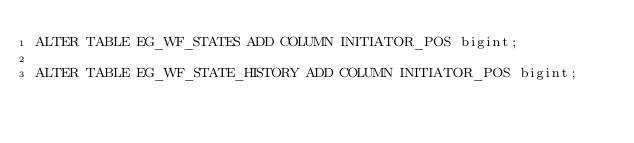<code> <loc_0><loc_0><loc_500><loc_500><_SQL_>ALTER TABLE EG_WF_STATES ADD COLUMN INITIATOR_POS bigint;

ALTER TABLE EG_WF_STATE_HISTORY ADD COLUMN INITIATOR_POS bigint;</code> 